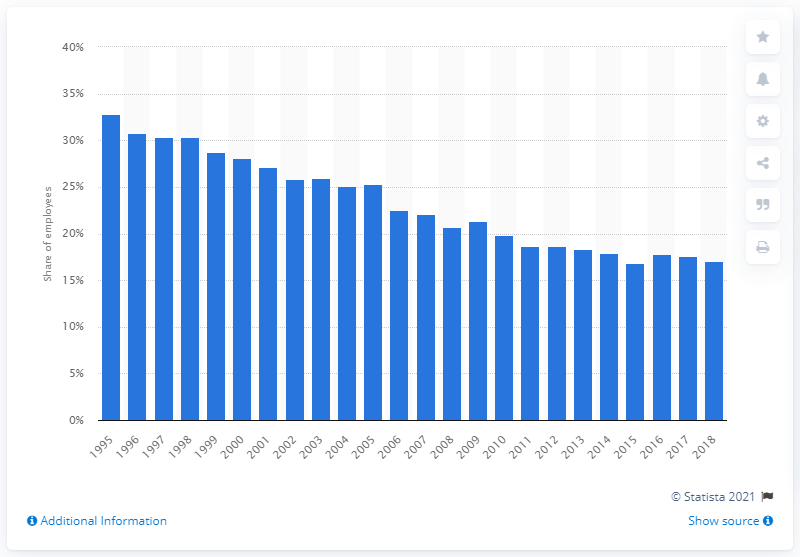Point out several critical features in this image. At the beginning of this period, the peak union density was 32.8%. In the most recent survey, 17.1% of manufacturing workers were found to be members of a trade union. 